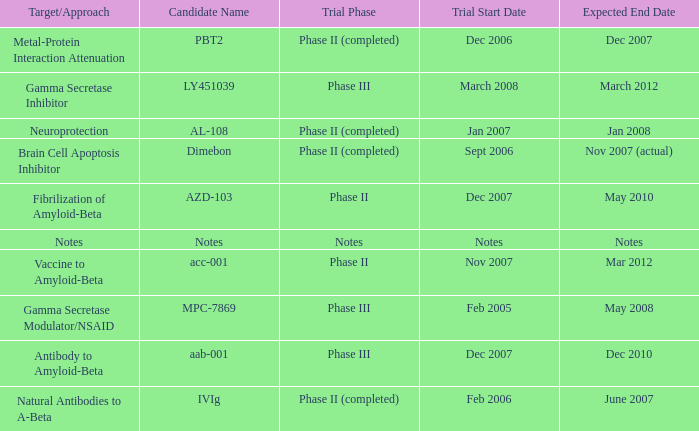What is Trial Start Date, when Candidate Name is PBT2? Dec 2006. 